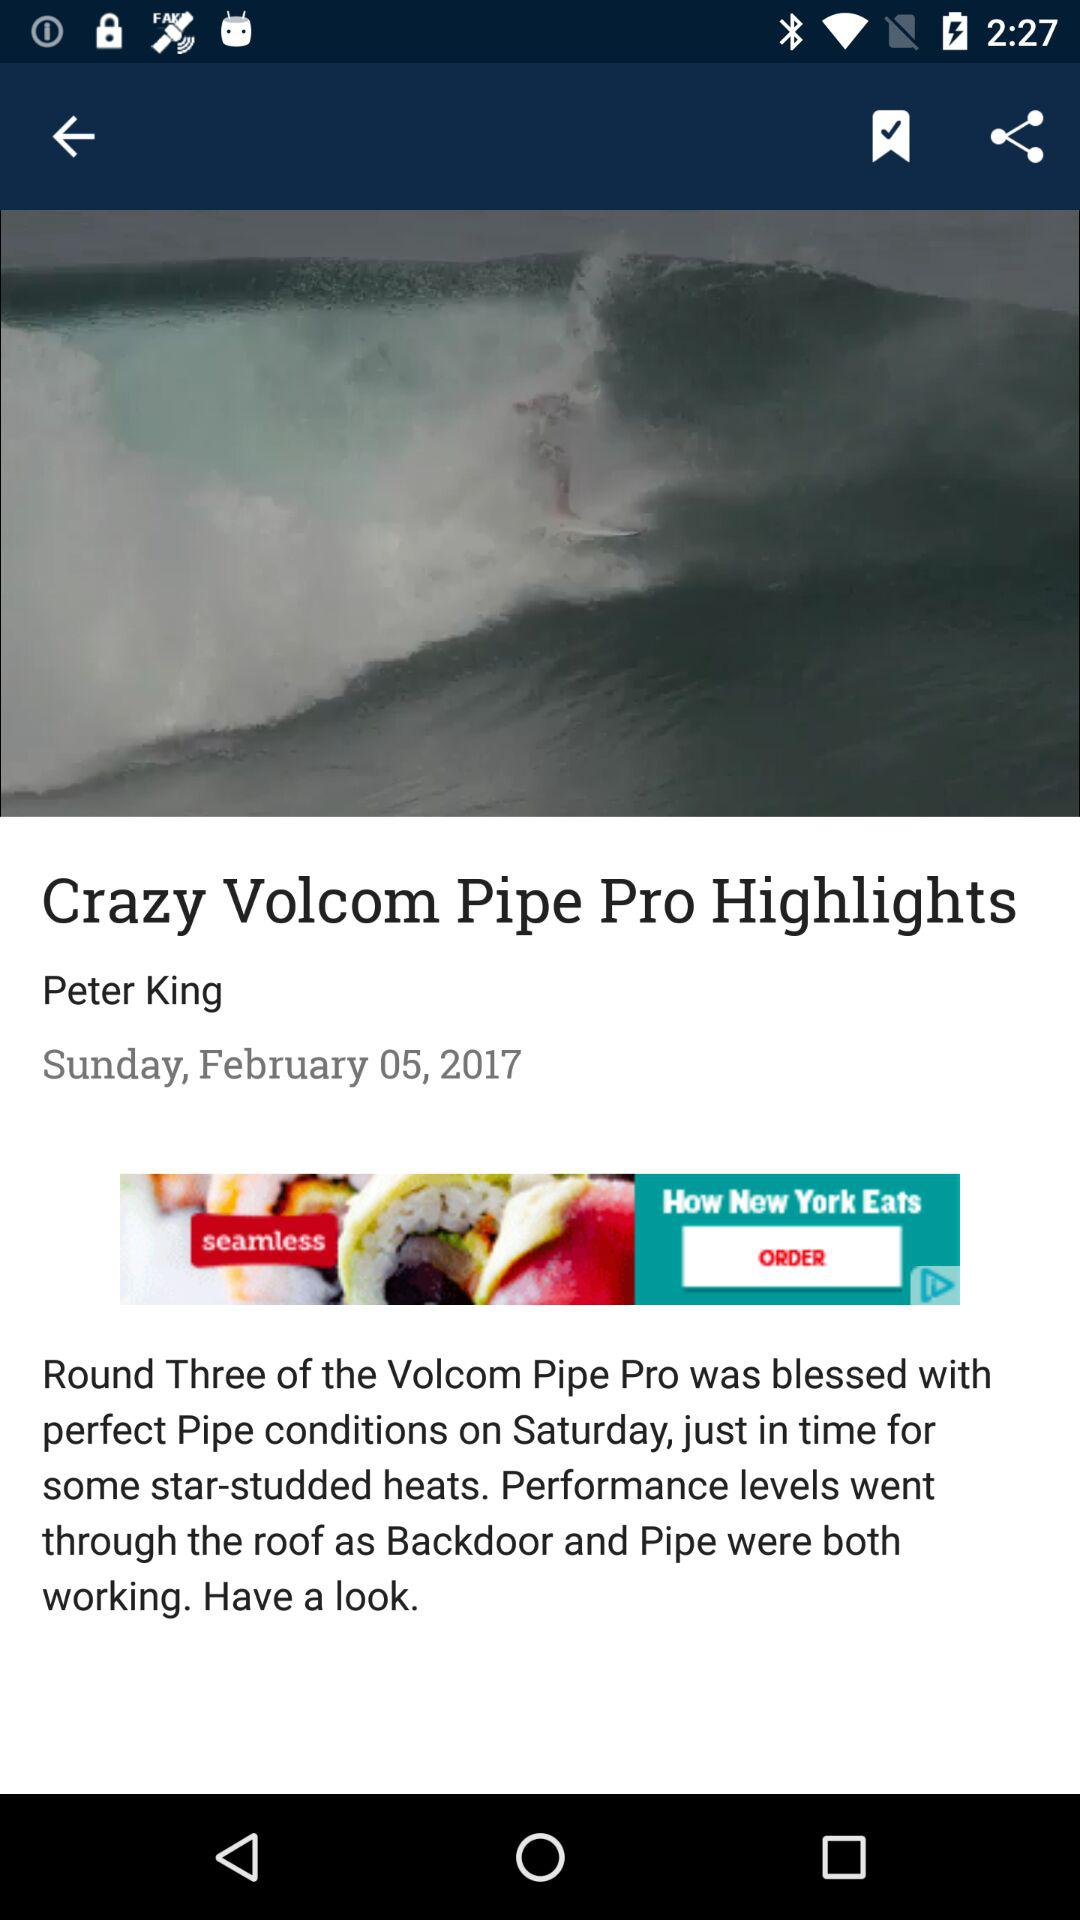What is the publication date? The publication date is Sunday, February 5, 2017. 